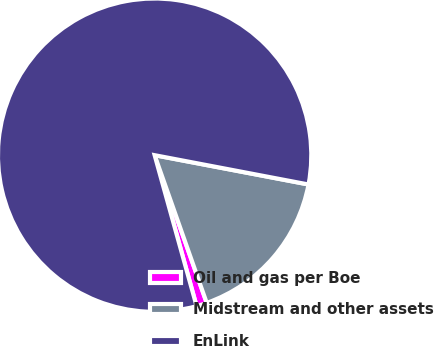Convert chart to OTSL. <chart><loc_0><loc_0><loc_500><loc_500><pie_chart><fcel>Oil and gas per Boe<fcel>Midstream and other assets<fcel>EnLink<nl><fcel>1.08%<fcel>16.61%<fcel>82.31%<nl></chart> 